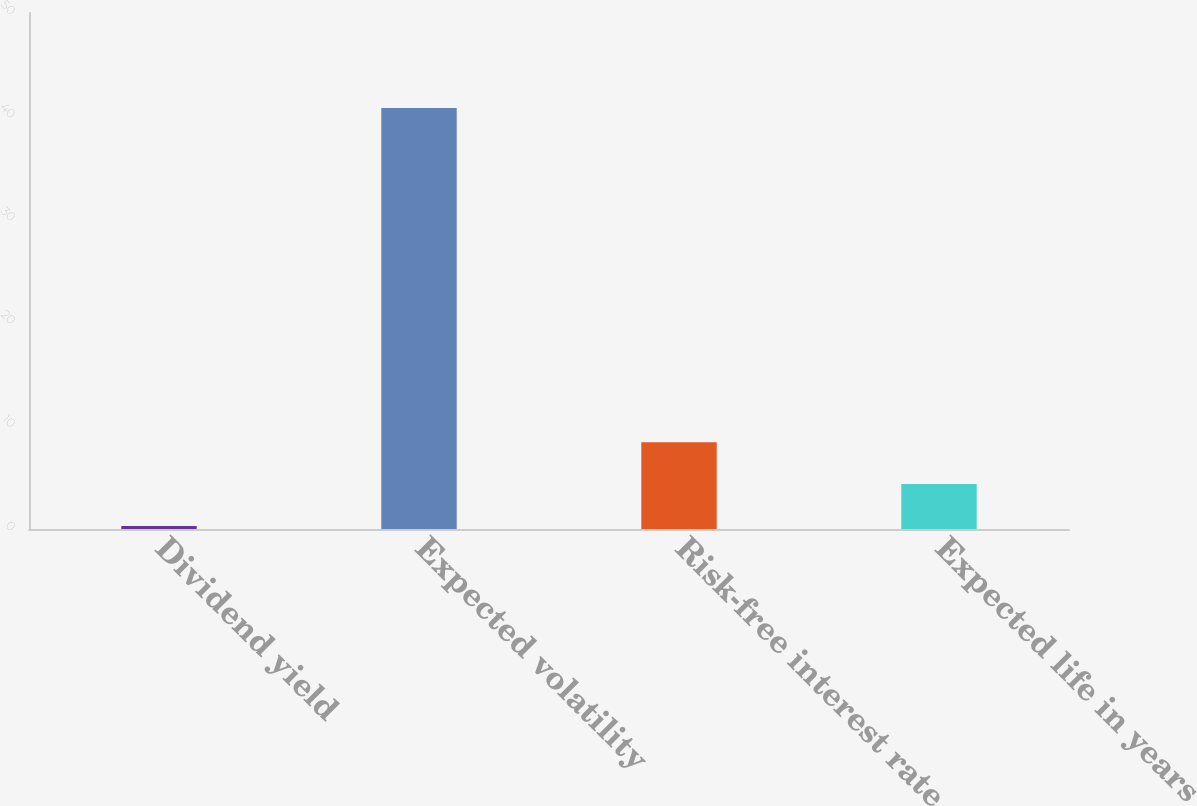<chart> <loc_0><loc_0><loc_500><loc_500><bar_chart><fcel>Dividend yield<fcel>Expected volatility<fcel>Risk-free interest rate<fcel>Expected life in years<nl><fcel>0.3<fcel>40.8<fcel>8.4<fcel>4.35<nl></chart> 